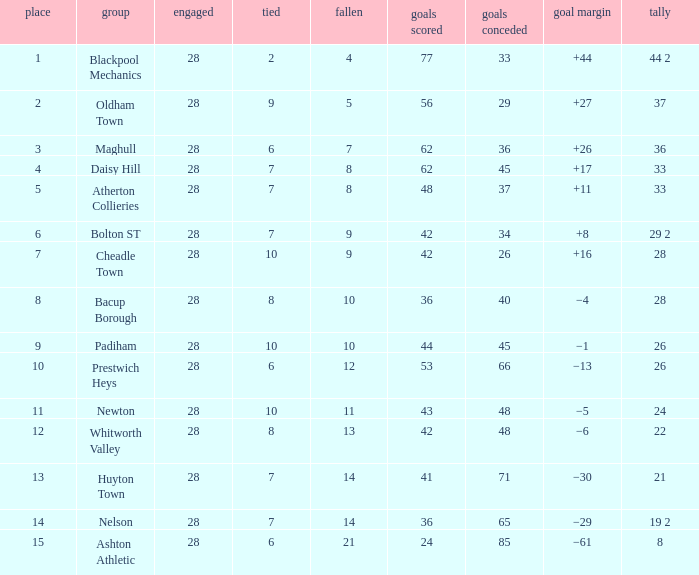For entries with fewer than 28 played, with 45 goals against and points 1 of 33, what is the average drawn? None. 